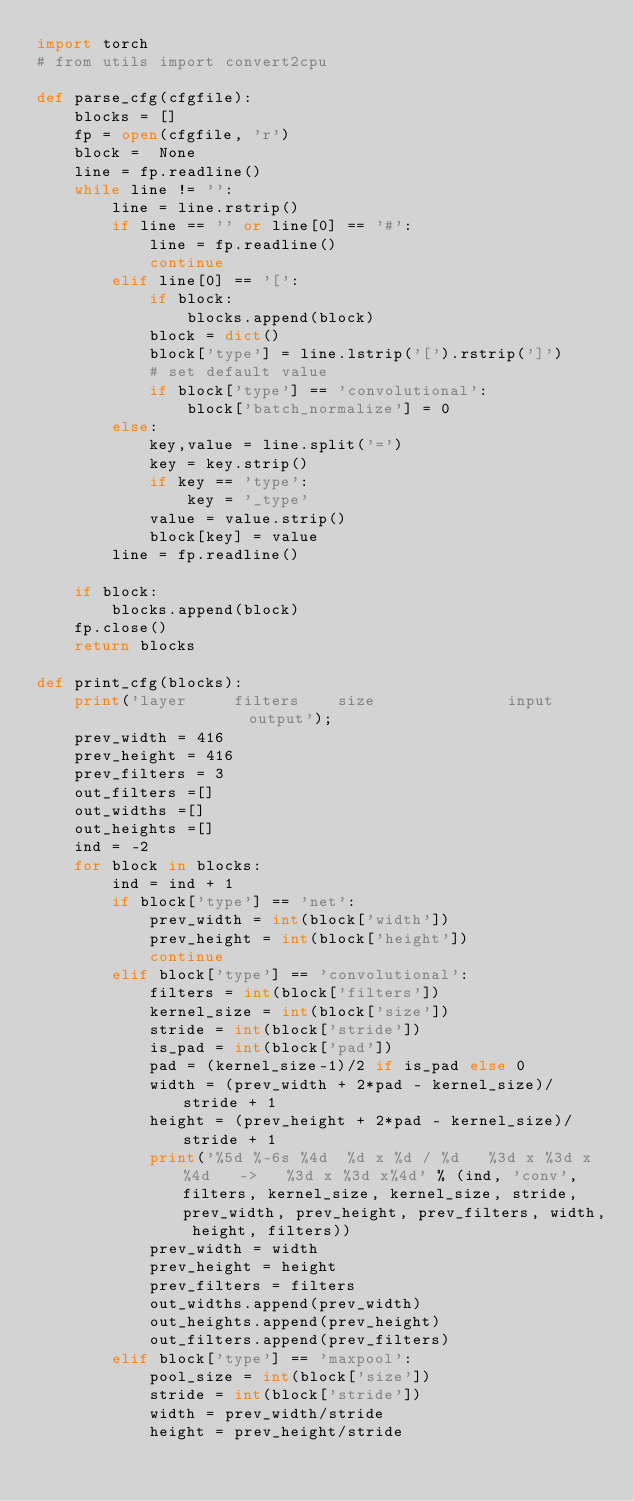<code> <loc_0><loc_0><loc_500><loc_500><_Python_>import torch
# from utils import convert2cpu

def parse_cfg(cfgfile):
    blocks = []
    fp = open(cfgfile, 'r')
    block =  None
    line = fp.readline()
    while line != '':
        line = line.rstrip()
        if line == '' or line[0] == '#':
            line = fp.readline()
            continue        
        elif line[0] == '[':
            if block:
                blocks.append(block)
            block = dict()
            block['type'] = line.lstrip('[').rstrip(']')
            # set default value
            if block['type'] == 'convolutional':
                block['batch_normalize'] = 0
        else:
            key,value = line.split('=')
            key = key.strip()
            if key == 'type':
                key = '_type'
            value = value.strip()
            block[key] = value
        line = fp.readline()

    if block:
        blocks.append(block)
    fp.close()
    return blocks

def print_cfg(blocks):
    print('layer     filters    size              input                output');
    prev_width = 416
    prev_height = 416
    prev_filters = 3
    out_filters =[]
    out_widths =[]
    out_heights =[]
    ind = -2
    for block in blocks:
        ind = ind + 1
        if block['type'] == 'net':
            prev_width = int(block['width'])
            prev_height = int(block['height'])
            continue
        elif block['type'] == 'convolutional':
            filters = int(block['filters'])
            kernel_size = int(block['size'])
            stride = int(block['stride'])
            is_pad = int(block['pad'])
            pad = (kernel_size-1)/2 if is_pad else 0
            width = (prev_width + 2*pad - kernel_size)/stride + 1
            height = (prev_height + 2*pad - kernel_size)/stride + 1
            print('%5d %-6s %4d  %d x %d / %d   %3d x %3d x%4d   ->   %3d x %3d x%4d' % (ind, 'conv', filters, kernel_size, kernel_size, stride, prev_width, prev_height, prev_filters, width, height, filters))
            prev_width = width
            prev_height = height
            prev_filters = filters
            out_widths.append(prev_width)
            out_heights.append(prev_height)
            out_filters.append(prev_filters)
        elif block['type'] == 'maxpool':
            pool_size = int(block['size'])
            stride = int(block['stride'])
            width = prev_width/stride
            height = prev_height/stride</code> 